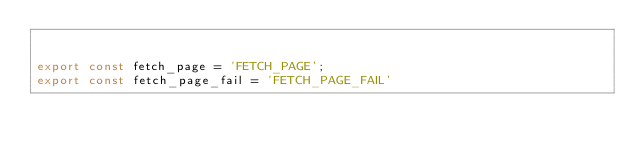Convert code to text. <code><loc_0><loc_0><loc_500><loc_500><_JavaScript_>

export const fetch_page = 'FETCH_PAGE';
export const fetch_page_fail = 'FETCH_PAGE_FAIL'</code> 